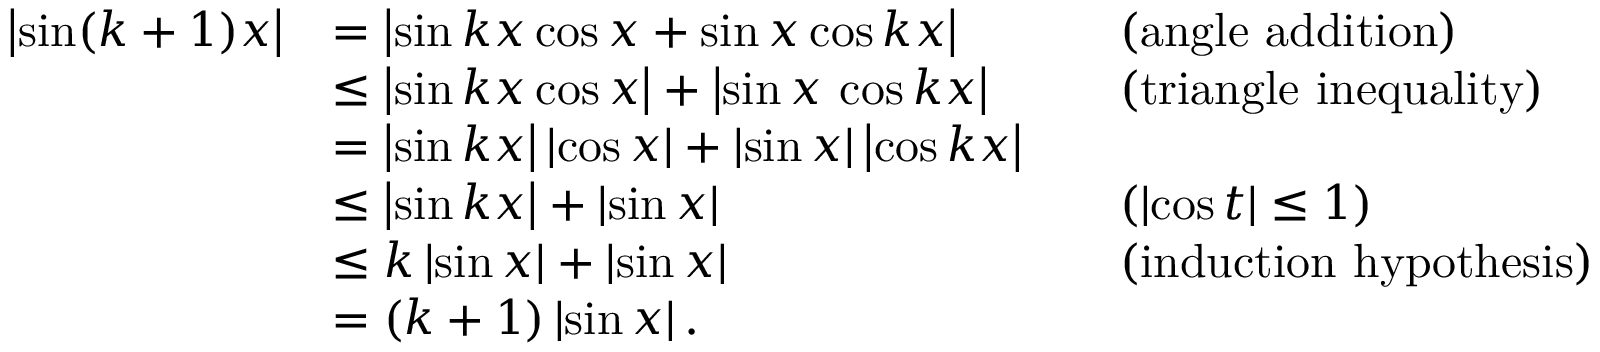<formula> <loc_0><loc_0><loc_500><loc_500>{ \begin{array} { r l r l } { \left | \sin ( k + 1 ) x \right | } & { = \left | \sin k x \cos x + \sin x \cos k x \right | } & & { ( a n g l e a d d i t i o n ) } \\ & { \leq \left | \sin k x \cos x \right | + \left | \sin x \, \cos k x \right | } & & { ( t r i a n g l e i n e q u a l i t y ) } \\ & { = \left | \sin k x \right | \left | \cos x \right | + \left | \sin x \right | \left | \cos k x \right | } \\ & { \leq \left | \sin k x \right | + \left | \sin x \right | } & & { ( \left | \cos t \right | \leq 1 ) } \\ & { \leq k \left | \sin x \right | + \left | \sin x \right | } & & { { ( i n d u c t i o n h y p o t h e s i s } ) } \\ & { = ( k + 1 ) \left | \sin x \right | . } \end{array} }</formula> 